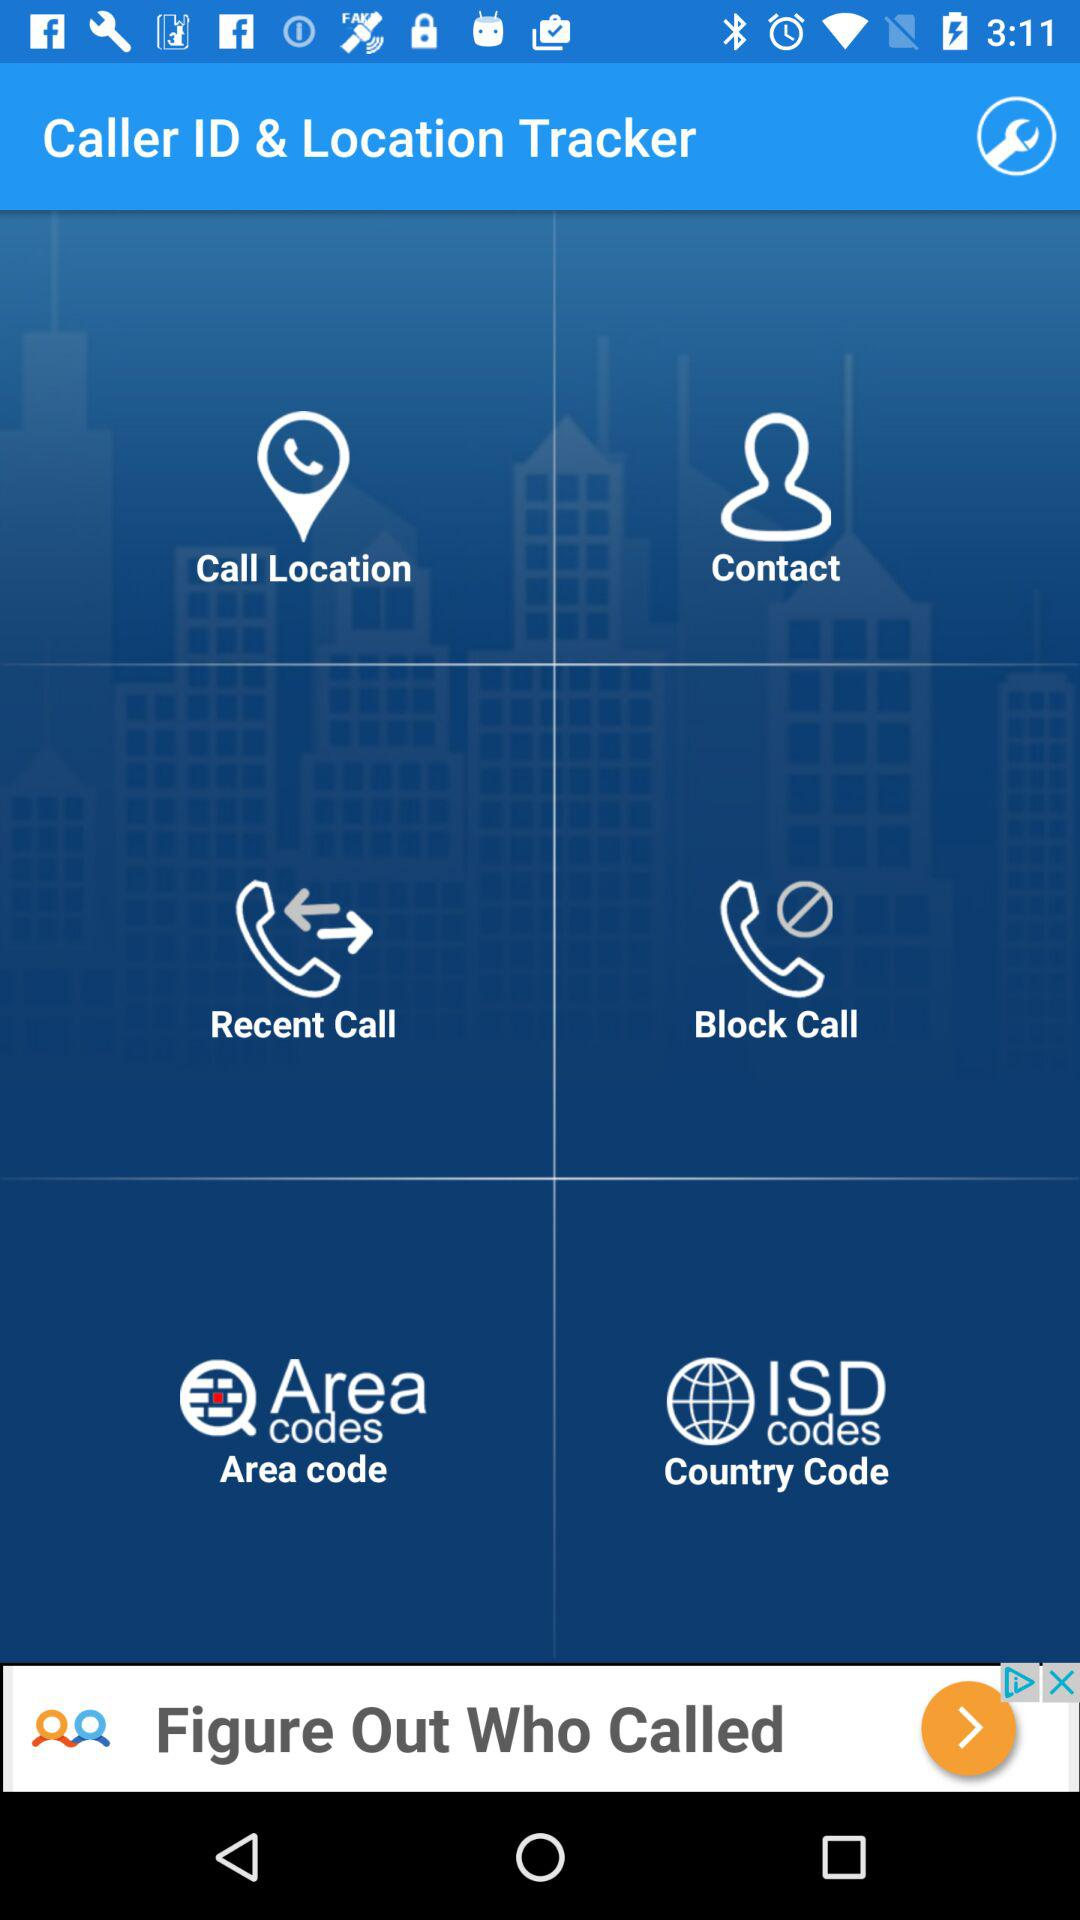What's the application name? The application name is "Caller ID & Location Tracker". 